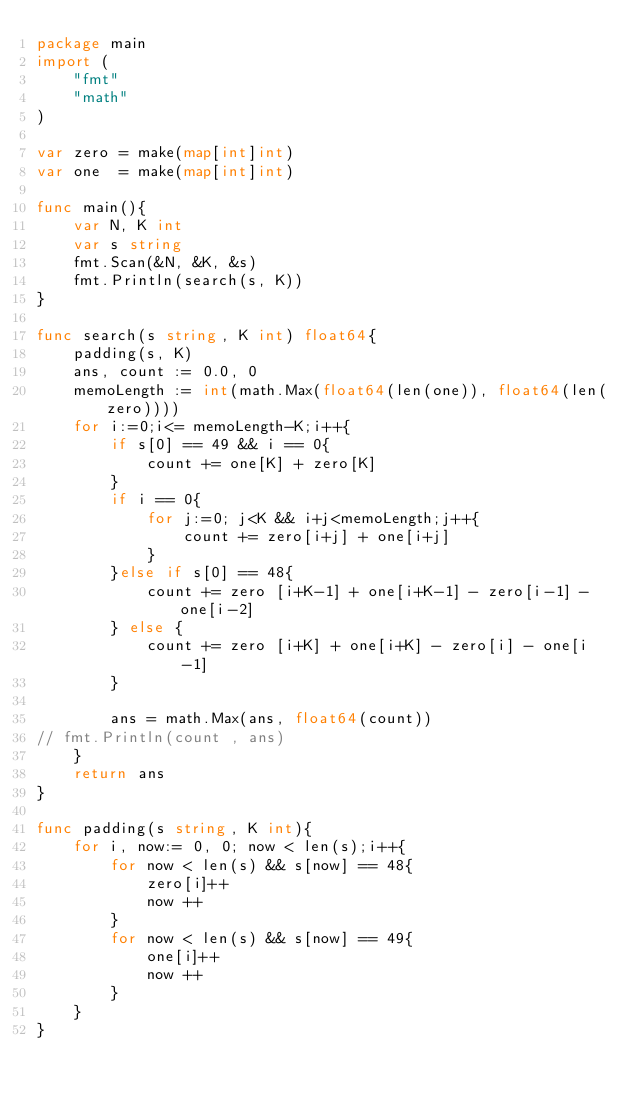<code> <loc_0><loc_0><loc_500><loc_500><_Go_>package main
import (
    "fmt"
    "math"
)

var zero = make(map[int]int)
var one  = make(map[int]int)

func main(){
    var N, K int
    var s string
    fmt.Scan(&N, &K, &s)
    fmt.Println(search(s, K))
}

func search(s string, K int) float64{
    padding(s, K)
    ans, count := 0.0, 0
    memoLength := int(math.Max(float64(len(one)), float64(len(zero))))
    for i:=0;i<= memoLength-K;i++{
        if s[0] == 49 && i == 0{
            count += one[K] + zero[K]
        }
        if i == 0{
            for j:=0; j<K && i+j<memoLength;j++{
                count += zero[i+j] + one[i+j]
            }
        }else if s[0] == 48{
            count += zero [i+K-1] + one[i+K-1] - zero[i-1] - one[i-2]
        } else {
            count += zero [i+K] + one[i+K] - zero[i] - one[i-1]
        }
        
        ans = math.Max(ans, float64(count))
// fmt.Println(count , ans)
    } 
    return ans
}

func padding(s string, K int){
    for i, now:= 0, 0; now < len(s);i++{
        for now < len(s) && s[now] == 48{
            zero[i]++
            now ++
        }
        for now < len(s) && s[now] == 49{
            one[i]++
            now ++
        }
    }
}
</code> 